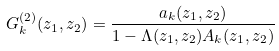Convert formula to latex. <formula><loc_0><loc_0><loc_500><loc_500>G _ { k } ^ { ( 2 ) } ( z _ { 1 } , z _ { 2 } ) = \frac { a _ { k } ( z _ { 1 } , z _ { 2 } ) } { 1 - \Lambda ( z _ { 1 } , z _ { 2 } ) A _ { k } ( z _ { 1 } , z _ { 2 } ) }</formula> 